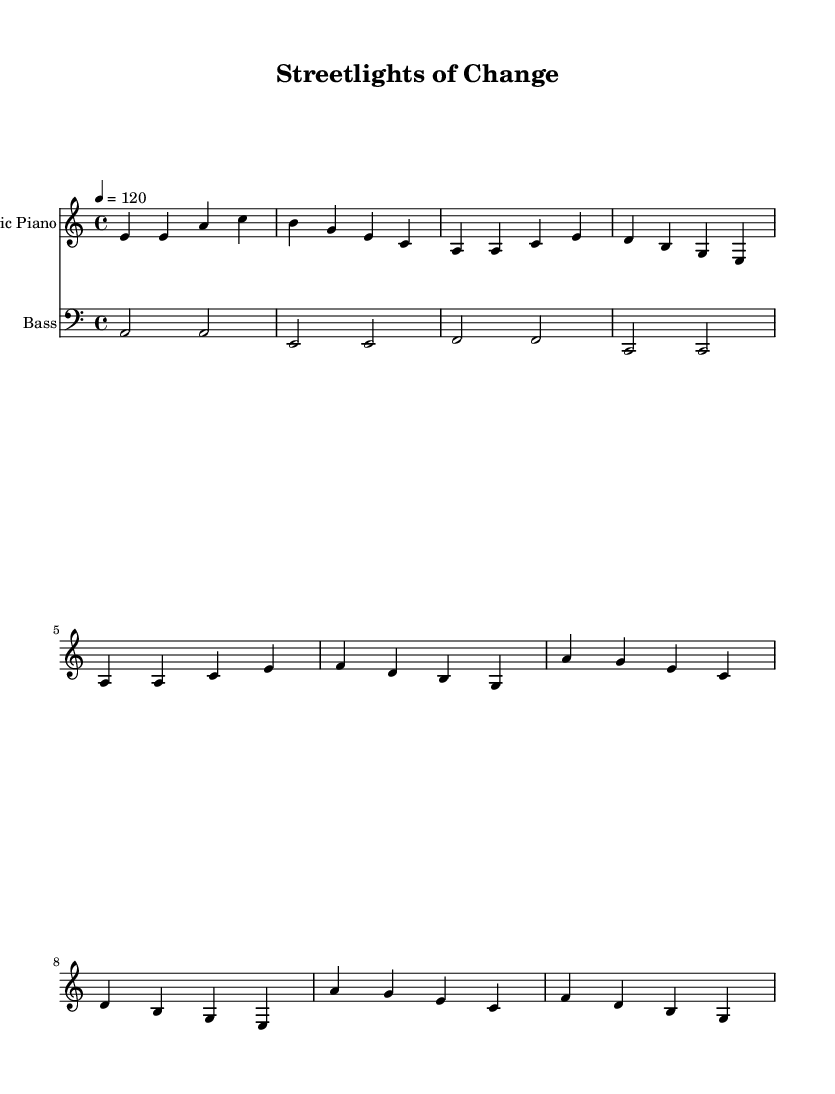What is the key signature of this music? The key signature is A minor, which consists of no sharps and has the note A as its tonic. This can be identified by looking at the initial section of the score where the key is indicated.
Answer: A minor What is the tempo marking for this piece? The tempo marking is indicated as "4 = 120," which means there are 120 beats per minute at a quarter note, displayed in the header section of the score. This shows the speed at which the music should be played.
Answer: 120 What is the time signature of this music? The time signature is 4/4, indicated at the beginning of the score, meaning there are four beats in each measure and the quarter note gets one beat. This standard time signature is common in Disco music, which typically has a four-beat pulse.
Answer: 4/4 How many measures are in the verse section? The verse section consists of four measures, which can be counted by segmenting the notes in the verse labeled part of the score. Each distinct grouping separated by the vertical lines represents one measure.
Answer: 4 Which instrument is labeled as having a treble clef? The instrument with the treble clef is the Electric Piano, as shown at the beginning of its staff. The clef indicates that the notes on this staff will be higher in pitch, suitable for the piano's range.
Answer: Electric Piano What is the first note played in the chorus section? The first note played in the chorus is A, which can be identified as the very first note of the chorus grouping at the beginning of that section. This note sets the melodic line for the chorus.
Answer: A Which instrument plays the bassline? The instrument that plays the bassline is the Bass, as indicated by its label on the staff at the start, generally characterized by its lower pitch range played in a broad rhythm.
Answer: Bass 